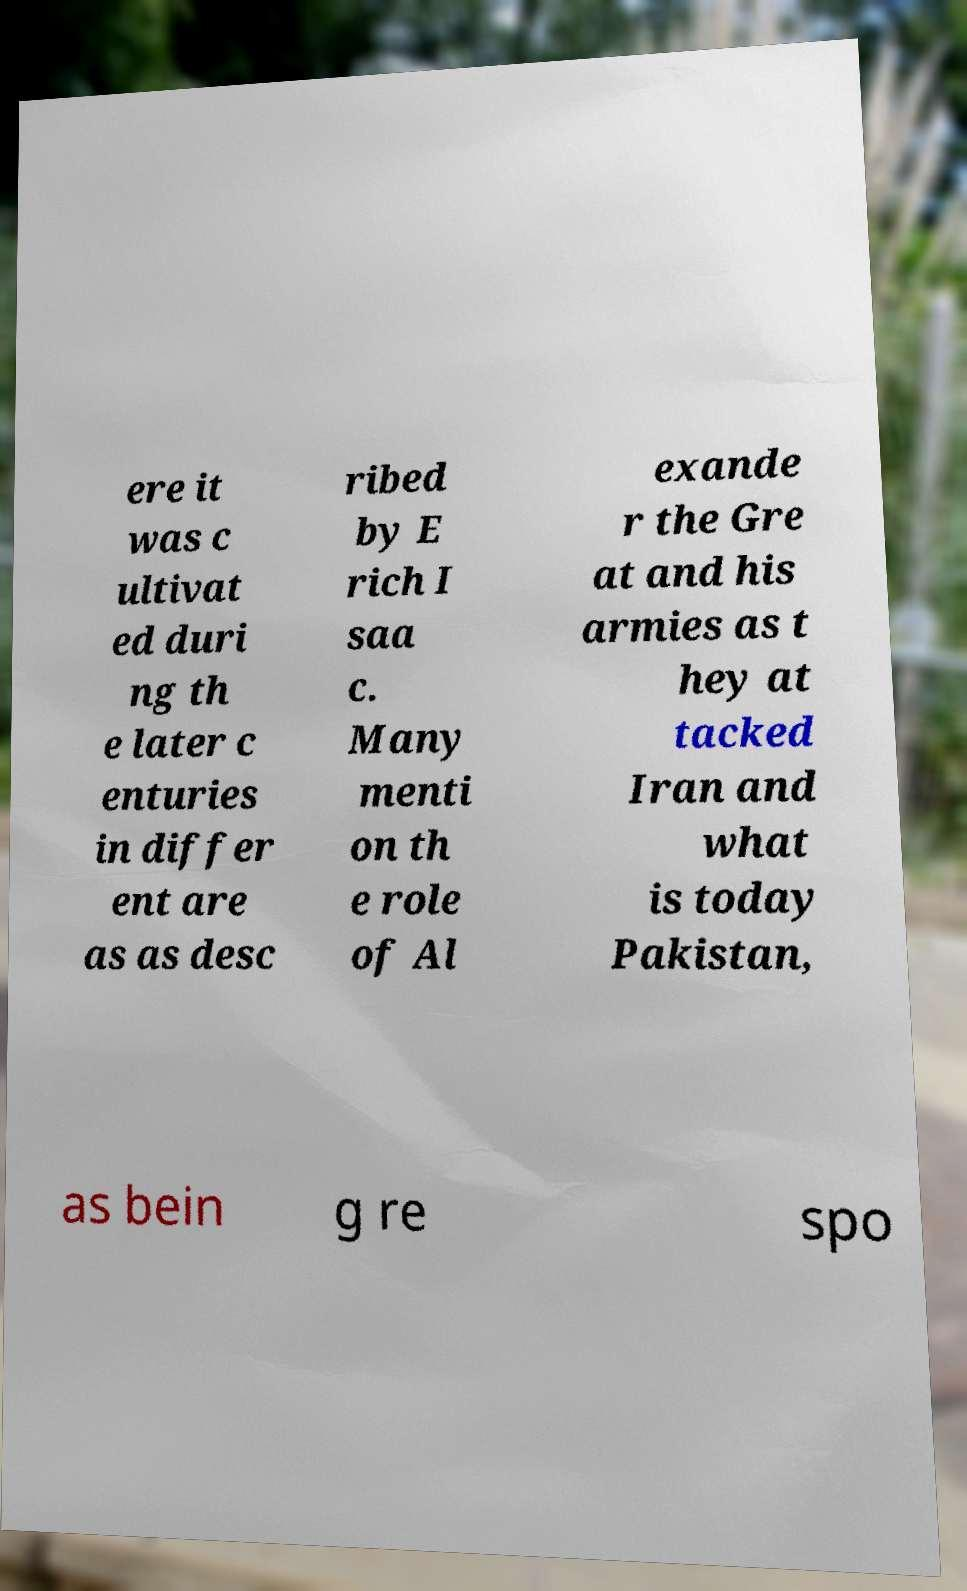Please read and relay the text visible in this image. What does it say? ere it was c ultivat ed duri ng th e later c enturies in differ ent are as as desc ribed by E rich I saa c. Many menti on th e role of Al exande r the Gre at and his armies as t hey at tacked Iran and what is today Pakistan, as bein g re spo 